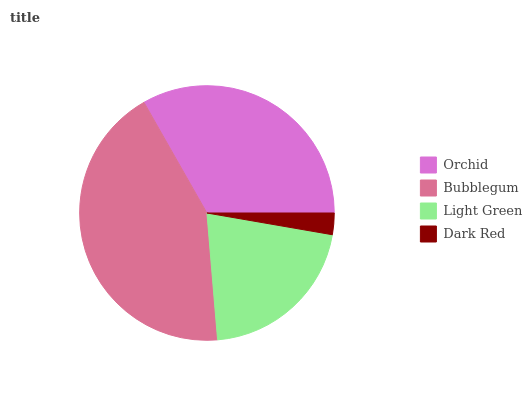Is Dark Red the minimum?
Answer yes or no. Yes. Is Bubblegum the maximum?
Answer yes or no. Yes. Is Light Green the minimum?
Answer yes or no. No. Is Light Green the maximum?
Answer yes or no. No. Is Bubblegum greater than Light Green?
Answer yes or no. Yes. Is Light Green less than Bubblegum?
Answer yes or no. Yes. Is Light Green greater than Bubblegum?
Answer yes or no. No. Is Bubblegum less than Light Green?
Answer yes or no. No. Is Orchid the high median?
Answer yes or no. Yes. Is Light Green the low median?
Answer yes or no. Yes. Is Bubblegum the high median?
Answer yes or no. No. Is Bubblegum the low median?
Answer yes or no. No. 